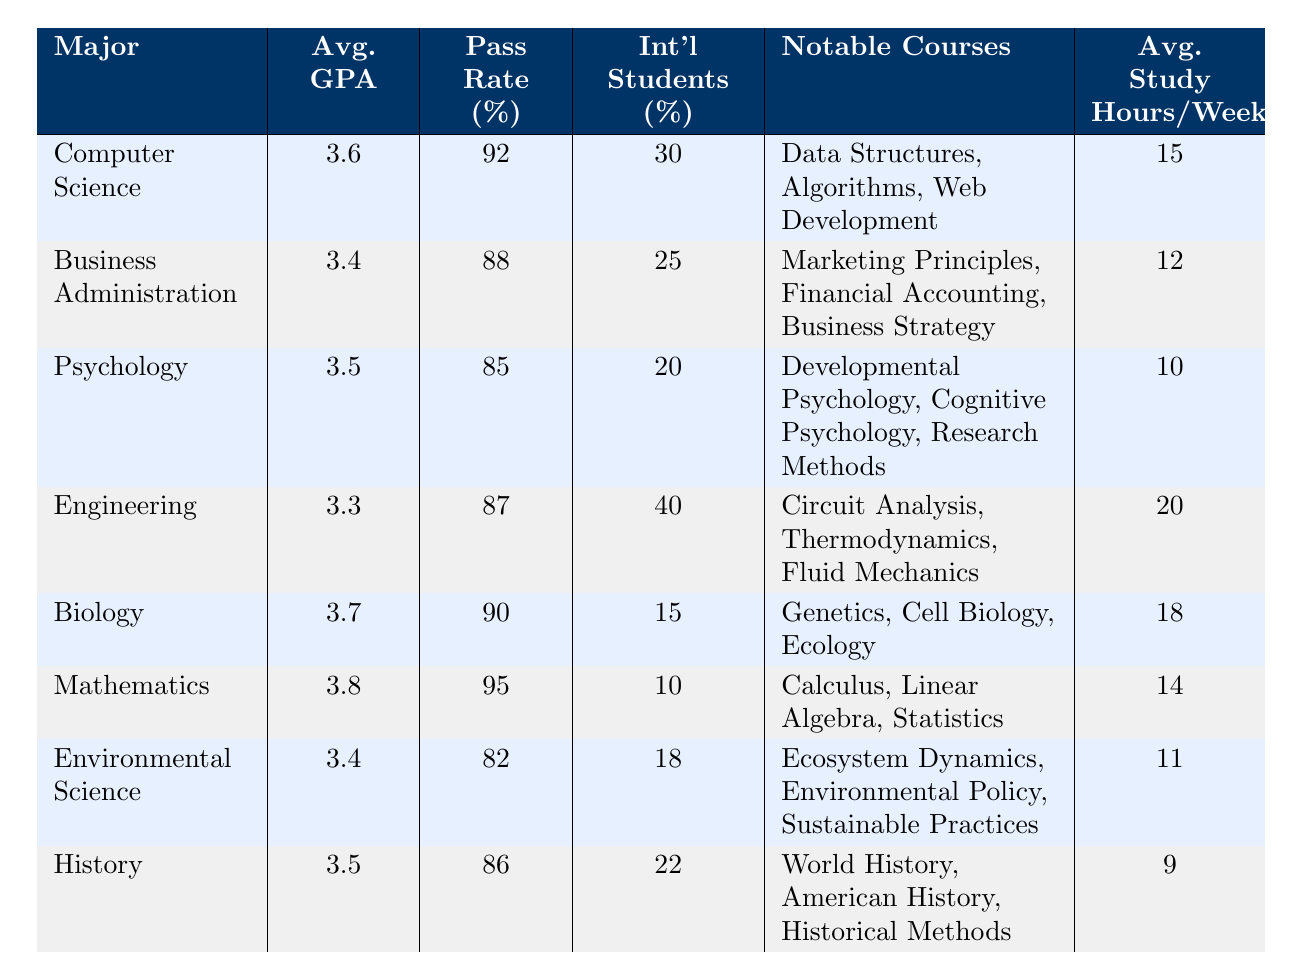What is the average GPA for Mathematics? The table shows that the average GPA for the Mathematics major is directly listed as 3.8.
Answer: 3.8 Which major has the highest pass rate? By examining the 'Pass Rate' column, the highest pass rate is 95% for the Mathematics major, making it the major with the highest pass rate.
Answer: Mathematics What is the average study hours per week for Business Administration students? The table indicates the average study hours per week for Business Administration is directly listed as 12 hours.
Answer: 12 Are there more international students in Engineering than in Psychology? The international student percentage for Engineering is 40%, while for Psychology, it is 20%. Since 40% is greater than 20%, the answer is yes.
Answer: Yes What is the difference in average GPA between Computer Science and Biology? The average GPA for Computer Science is 3.6 and for Biology, it is 3.7. The difference is calculated as 3.7 - 3.6 = 0.1.
Answer: 0.1 Which major has the lowest average study hours per week, and what is that number? By reviewing the study hours per week, we find that History has the lowest average study hours, which is 9 hours.
Answer: History, 9 What percentage of international students is there in Biology compared to Mathematics? The international student percentage for Biology is 15%, and for Mathematics, it is 10%. Since 15% is greater than 10%, Biology has a higher percentage of international students.
Answer: Yes What is the average GPA of the majors with a pass rate above 90%? The majors with a pass rate above 90% are Mathematics (3.8), Computer Science (3.6), and Biology (3.7). Their average GPA is calculated as (3.8 + 3.6 + 3.7) / 3 = 3.7.
Answer: 3.7 What notable courses are listed for Engineering? The table lists that notable courses for Engineering are Circuit Analysis, Thermodynamics, and Fluid Mechanics.
Answer: Circuit Analysis, Thermodynamics, Fluid Mechanics 